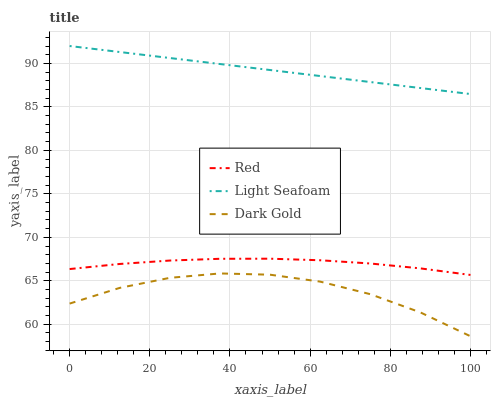Does Dark Gold have the minimum area under the curve?
Answer yes or no. Yes. Does Red have the minimum area under the curve?
Answer yes or no. No. Does Red have the maximum area under the curve?
Answer yes or no. No. Is Dark Gold the roughest?
Answer yes or no. Yes. Is Red the smoothest?
Answer yes or no. No. Is Red the roughest?
Answer yes or no. No. Does Red have the lowest value?
Answer yes or no. No. Does Red have the highest value?
Answer yes or no. No. Is Red less than Light Seafoam?
Answer yes or no. Yes. Is Red greater than Dark Gold?
Answer yes or no. Yes. Does Red intersect Light Seafoam?
Answer yes or no. No. 